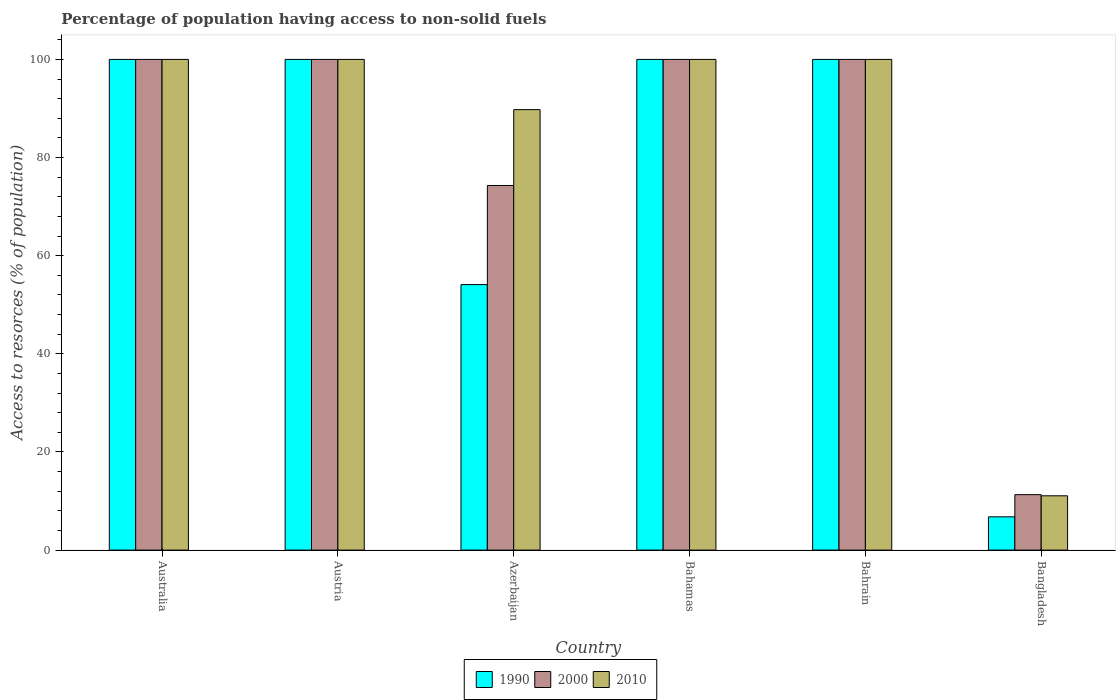Are the number of bars on each tick of the X-axis equal?
Your answer should be compact. Yes. How many bars are there on the 4th tick from the right?
Keep it short and to the point. 3. What is the label of the 1st group of bars from the left?
Offer a very short reply. Australia. Across all countries, what is the minimum percentage of population having access to non-solid fuels in 1990?
Provide a short and direct response. 6.78. In which country was the percentage of population having access to non-solid fuels in 2000 maximum?
Your answer should be very brief. Australia. What is the total percentage of population having access to non-solid fuels in 1990 in the graph?
Your answer should be very brief. 460.89. What is the difference between the percentage of population having access to non-solid fuels in 2010 in Bahamas and that in Bangladesh?
Offer a terse response. 88.93. What is the average percentage of population having access to non-solid fuels in 2010 per country?
Provide a succinct answer. 83.47. What is the difference between the percentage of population having access to non-solid fuels of/in 1990 and percentage of population having access to non-solid fuels of/in 2000 in Bahamas?
Offer a very short reply. 0. In how many countries, is the percentage of population having access to non-solid fuels in 2010 greater than 72 %?
Keep it short and to the point. 5. What is the ratio of the percentage of population having access to non-solid fuels in 2000 in Azerbaijan to that in Bangladesh?
Your answer should be compact. 6.57. Is the percentage of population having access to non-solid fuels in 1990 in Australia less than that in Bahamas?
Keep it short and to the point. No. What is the difference between the highest and the lowest percentage of population having access to non-solid fuels in 2000?
Make the answer very short. 88.7. Is the sum of the percentage of population having access to non-solid fuels in 2000 in Australia and Azerbaijan greater than the maximum percentage of population having access to non-solid fuels in 1990 across all countries?
Make the answer very short. Yes. What does the 1st bar from the left in Azerbaijan represents?
Provide a succinct answer. 1990. What does the 3rd bar from the right in Australia represents?
Offer a terse response. 1990. Is it the case that in every country, the sum of the percentage of population having access to non-solid fuels in 1990 and percentage of population having access to non-solid fuels in 2010 is greater than the percentage of population having access to non-solid fuels in 2000?
Ensure brevity in your answer.  Yes. How many bars are there?
Your answer should be very brief. 18. How many countries are there in the graph?
Make the answer very short. 6. Are the values on the major ticks of Y-axis written in scientific E-notation?
Your answer should be very brief. No. Does the graph contain grids?
Your response must be concise. No. What is the title of the graph?
Your answer should be compact. Percentage of population having access to non-solid fuels. Does "2010" appear as one of the legend labels in the graph?
Offer a very short reply. Yes. What is the label or title of the Y-axis?
Your answer should be very brief. Access to resorces (% of population). What is the Access to resorces (% of population) of 2000 in Australia?
Provide a succinct answer. 100. What is the Access to resorces (% of population) of 2010 in Australia?
Your response must be concise. 100. What is the Access to resorces (% of population) in 1990 in Austria?
Your answer should be very brief. 100. What is the Access to resorces (% of population) in 1990 in Azerbaijan?
Provide a short and direct response. 54.11. What is the Access to resorces (% of population) of 2000 in Azerbaijan?
Keep it short and to the point. 74.31. What is the Access to resorces (% of population) in 2010 in Azerbaijan?
Your answer should be compact. 89.76. What is the Access to resorces (% of population) in 2000 in Bahamas?
Ensure brevity in your answer.  100. What is the Access to resorces (% of population) of 1990 in Bahrain?
Keep it short and to the point. 100. What is the Access to resorces (% of population) of 2000 in Bahrain?
Your answer should be compact. 100. What is the Access to resorces (% of population) in 2010 in Bahrain?
Provide a succinct answer. 100. What is the Access to resorces (% of population) of 1990 in Bangladesh?
Provide a short and direct response. 6.78. What is the Access to resorces (% of population) in 2000 in Bangladesh?
Provide a short and direct response. 11.3. What is the Access to resorces (% of population) of 2010 in Bangladesh?
Offer a terse response. 11.07. Across all countries, what is the maximum Access to resorces (% of population) of 2000?
Give a very brief answer. 100. Across all countries, what is the maximum Access to resorces (% of population) in 2010?
Your answer should be very brief. 100. Across all countries, what is the minimum Access to resorces (% of population) in 1990?
Ensure brevity in your answer.  6.78. Across all countries, what is the minimum Access to resorces (% of population) in 2000?
Give a very brief answer. 11.3. Across all countries, what is the minimum Access to resorces (% of population) in 2010?
Provide a succinct answer. 11.07. What is the total Access to resorces (% of population) in 1990 in the graph?
Keep it short and to the point. 460.89. What is the total Access to resorces (% of population) in 2000 in the graph?
Provide a succinct answer. 485.61. What is the total Access to resorces (% of population) in 2010 in the graph?
Provide a short and direct response. 500.83. What is the difference between the Access to resorces (% of population) in 2000 in Australia and that in Austria?
Make the answer very short. 0. What is the difference between the Access to resorces (% of population) in 1990 in Australia and that in Azerbaijan?
Provide a succinct answer. 45.89. What is the difference between the Access to resorces (% of population) in 2000 in Australia and that in Azerbaijan?
Provide a short and direct response. 25.69. What is the difference between the Access to resorces (% of population) of 2010 in Australia and that in Azerbaijan?
Provide a short and direct response. 10.24. What is the difference between the Access to resorces (% of population) in 1990 in Australia and that in Bahamas?
Offer a terse response. 0. What is the difference between the Access to resorces (% of population) in 2000 in Australia and that in Bahamas?
Provide a short and direct response. 0. What is the difference between the Access to resorces (% of population) in 2000 in Australia and that in Bahrain?
Keep it short and to the point. 0. What is the difference between the Access to resorces (% of population) of 1990 in Australia and that in Bangladesh?
Give a very brief answer. 93.22. What is the difference between the Access to resorces (% of population) in 2000 in Australia and that in Bangladesh?
Your response must be concise. 88.7. What is the difference between the Access to resorces (% of population) of 2010 in Australia and that in Bangladesh?
Your answer should be very brief. 88.93. What is the difference between the Access to resorces (% of population) in 1990 in Austria and that in Azerbaijan?
Make the answer very short. 45.89. What is the difference between the Access to resorces (% of population) in 2000 in Austria and that in Azerbaijan?
Offer a very short reply. 25.69. What is the difference between the Access to resorces (% of population) of 2010 in Austria and that in Azerbaijan?
Provide a short and direct response. 10.24. What is the difference between the Access to resorces (% of population) in 2000 in Austria and that in Bahamas?
Your answer should be compact. 0. What is the difference between the Access to resorces (% of population) of 2010 in Austria and that in Bahrain?
Ensure brevity in your answer.  0. What is the difference between the Access to resorces (% of population) of 1990 in Austria and that in Bangladesh?
Provide a short and direct response. 93.22. What is the difference between the Access to resorces (% of population) of 2000 in Austria and that in Bangladesh?
Your answer should be very brief. 88.7. What is the difference between the Access to resorces (% of population) of 2010 in Austria and that in Bangladesh?
Offer a terse response. 88.93. What is the difference between the Access to resorces (% of population) of 1990 in Azerbaijan and that in Bahamas?
Provide a succinct answer. -45.89. What is the difference between the Access to resorces (% of population) in 2000 in Azerbaijan and that in Bahamas?
Your response must be concise. -25.69. What is the difference between the Access to resorces (% of population) of 2010 in Azerbaijan and that in Bahamas?
Your answer should be compact. -10.24. What is the difference between the Access to resorces (% of population) of 1990 in Azerbaijan and that in Bahrain?
Your answer should be very brief. -45.89. What is the difference between the Access to resorces (% of population) in 2000 in Azerbaijan and that in Bahrain?
Offer a very short reply. -25.69. What is the difference between the Access to resorces (% of population) in 2010 in Azerbaijan and that in Bahrain?
Your response must be concise. -10.24. What is the difference between the Access to resorces (% of population) in 1990 in Azerbaijan and that in Bangladesh?
Your answer should be very brief. 47.32. What is the difference between the Access to resorces (% of population) in 2000 in Azerbaijan and that in Bangladesh?
Your answer should be very brief. 63.01. What is the difference between the Access to resorces (% of population) of 2010 in Azerbaijan and that in Bangladesh?
Your answer should be compact. 78.7. What is the difference between the Access to resorces (% of population) in 2000 in Bahamas and that in Bahrain?
Your answer should be very brief. 0. What is the difference between the Access to resorces (% of population) of 1990 in Bahamas and that in Bangladesh?
Keep it short and to the point. 93.22. What is the difference between the Access to resorces (% of population) in 2000 in Bahamas and that in Bangladesh?
Offer a terse response. 88.7. What is the difference between the Access to resorces (% of population) of 2010 in Bahamas and that in Bangladesh?
Your response must be concise. 88.93. What is the difference between the Access to resorces (% of population) of 1990 in Bahrain and that in Bangladesh?
Your response must be concise. 93.22. What is the difference between the Access to resorces (% of population) in 2000 in Bahrain and that in Bangladesh?
Offer a terse response. 88.7. What is the difference between the Access to resorces (% of population) of 2010 in Bahrain and that in Bangladesh?
Provide a short and direct response. 88.93. What is the difference between the Access to resorces (% of population) of 1990 in Australia and the Access to resorces (% of population) of 2000 in Austria?
Provide a short and direct response. 0. What is the difference between the Access to resorces (% of population) of 1990 in Australia and the Access to resorces (% of population) of 2010 in Austria?
Your answer should be very brief. 0. What is the difference between the Access to resorces (% of population) of 2000 in Australia and the Access to resorces (% of population) of 2010 in Austria?
Offer a very short reply. 0. What is the difference between the Access to resorces (% of population) in 1990 in Australia and the Access to resorces (% of population) in 2000 in Azerbaijan?
Provide a short and direct response. 25.69. What is the difference between the Access to resorces (% of population) of 1990 in Australia and the Access to resorces (% of population) of 2010 in Azerbaijan?
Ensure brevity in your answer.  10.24. What is the difference between the Access to resorces (% of population) in 2000 in Australia and the Access to resorces (% of population) in 2010 in Azerbaijan?
Give a very brief answer. 10.24. What is the difference between the Access to resorces (% of population) in 2000 in Australia and the Access to resorces (% of population) in 2010 in Bahamas?
Offer a very short reply. 0. What is the difference between the Access to resorces (% of population) in 1990 in Australia and the Access to resorces (% of population) in 2010 in Bahrain?
Your answer should be compact. 0. What is the difference between the Access to resorces (% of population) in 1990 in Australia and the Access to resorces (% of population) in 2000 in Bangladesh?
Your answer should be very brief. 88.7. What is the difference between the Access to resorces (% of population) in 1990 in Australia and the Access to resorces (% of population) in 2010 in Bangladesh?
Provide a short and direct response. 88.93. What is the difference between the Access to resorces (% of population) in 2000 in Australia and the Access to resorces (% of population) in 2010 in Bangladesh?
Your response must be concise. 88.93. What is the difference between the Access to resorces (% of population) in 1990 in Austria and the Access to resorces (% of population) in 2000 in Azerbaijan?
Give a very brief answer. 25.69. What is the difference between the Access to resorces (% of population) in 1990 in Austria and the Access to resorces (% of population) in 2010 in Azerbaijan?
Provide a succinct answer. 10.24. What is the difference between the Access to resorces (% of population) of 2000 in Austria and the Access to resorces (% of population) of 2010 in Azerbaijan?
Ensure brevity in your answer.  10.24. What is the difference between the Access to resorces (% of population) of 1990 in Austria and the Access to resorces (% of population) of 2010 in Bahamas?
Keep it short and to the point. 0. What is the difference between the Access to resorces (% of population) of 1990 in Austria and the Access to resorces (% of population) of 2000 in Bahrain?
Your response must be concise. 0. What is the difference between the Access to resorces (% of population) in 2000 in Austria and the Access to resorces (% of population) in 2010 in Bahrain?
Make the answer very short. 0. What is the difference between the Access to resorces (% of population) in 1990 in Austria and the Access to resorces (% of population) in 2000 in Bangladesh?
Offer a terse response. 88.7. What is the difference between the Access to resorces (% of population) in 1990 in Austria and the Access to resorces (% of population) in 2010 in Bangladesh?
Offer a terse response. 88.93. What is the difference between the Access to resorces (% of population) of 2000 in Austria and the Access to resorces (% of population) of 2010 in Bangladesh?
Provide a succinct answer. 88.93. What is the difference between the Access to resorces (% of population) in 1990 in Azerbaijan and the Access to resorces (% of population) in 2000 in Bahamas?
Provide a succinct answer. -45.89. What is the difference between the Access to resorces (% of population) of 1990 in Azerbaijan and the Access to resorces (% of population) of 2010 in Bahamas?
Your answer should be compact. -45.89. What is the difference between the Access to resorces (% of population) in 2000 in Azerbaijan and the Access to resorces (% of population) in 2010 in Bahamas?
Your answer should be compact. -25.69. What is the difference between the Access to resorces (% of population) of 1990 in Azerbaijan and the Access to resorces (% of population) of 2000 in Bahrain?
Offer a very short reply. -45.89. What is the difference between the Access to resorces (% of population) in 1990 in Azerbaijan and the Access to resorces (% of population) in 2010 in Bahrain?
Offer a very short reply. -45.89. What is the difference between the Access to resorces (% of population) in 2000 in Azerbaijan and the Access to resorces (% of population) in 2010 in Bahrain?
Your answer should be compact. -25.69. What is the difference between the Access to resorces (% of population) of 1990 in Azerbaijan and the Access to resorces (% of population) of 2000 in Bangladesh?
Offer a very short reply. 42.8. What is the difference between the Access to resorces (% of population) in 1990 in Azerbaijan and the Access to resorces (% of population) in 2010 in Bangladesh?
Your answer should be compact. 43.04. What is the difference between the Access to resorces (% of population) in 2000 in Azerbaijan and the Access to resorces (% of population) in 2010 in Bangladesh?
Your response must be concise. 63.24. What is the difference between the Access to resorces (% of population) of 1990 in Bahamas and the Access to resorces (% of population) of 2010 in Bahrain?
Give a very brief answer. 0. What is the difference between the Access to resorces (% of population) of 2000 in Bahamas and the Access to resorces (% of population) of 2010 in Bahrain?
Keep it short and to the point. 0. What is the difference between the Access to resorces (% of population) of 1990 in Bahamas and the Access to resorces (% of population) of 2000 in Bangladesh?
Keep it short and to the point. 88.7. What is the difference between the Access to resorces (% of population) of 1990 in Bahamas and the Access to resorces (% of population) of 2010 in Bangladesh?
Give a very brief answer. 88.93. What is the difference between the Access to resorces (% of population) of 2000 in Bahamas and the Access to resorces (% of population) of 2010 in Bangladesh?
Provide a succinct answer. 88.93. What is the difference between the Access to resorces (% of population) in 1990 in Bahrain and the Access to resorces (% of population) in 2000 in Bangladesh?
Your answer should be very brief. 88.7. What is the difference between the Access to resorces (% of population) in 1990 in Bahrain and the Access to resorces (% of population) in 2010 in Bangladesh?
Your response must be concise. 88.93. What is the difference between the Access to resorces (% of population) of 2000 in Bahrain and the Access to resorces (% of population) of 2010 in Bangladesh?
Your response must be concise. 88.93. What is the average Access to resorces (% of population) of 1990 per country?
Provide a succinct answer. 76.81. What is the average Access to resorces (% of population) in 2000 per country?
Provide a succinct answer. 80.93. What is the average Access to resorces (% of population) of 2010 per country?
Your answer should be very brief. 83.47. What is the difference between the Access to resorces (% of population) of 1990 and Access to resorces (% of population) of 2000 in Australia?
Your response must be concise. 0. What is the difference between the Access to resorces (% of population) in 2000 and Access to resorces (% of population) in 2010 in Australia?
Ensure brevity in your answer.  0. What is the difference between the Access to resorces (% of population) of 1990 and Access to resorces (% of population) of 2010 in Austria?
Offer a very short reply. 0. What is the difference between the Access to resorces (% of population) of 2000 and Access to resorces (% of population) of 2010 in Austria?
Make the answer very short. 0. What is the difference between the Access to resorces (% of population) in 1990 and Access to resorces (% of population) in 2000 in Azerbaijan?
Your answer should be compact. -20.2. What is the difference between the Access to resorces (% of population) in 1990 and Access to resorces (% of population) in 2010 in Azerbaijan?
Provide a succinct answer. -35.66. What is the difference between the Access to resorces (% of population) of 2000 and Access to resorces (% of population) of 2010 in Azerbaijan?
Offer a terse response. -15.46. What is the difference between the Access to resorces (% of population) in 1990 and Access to resorces (% of population) in 2000 in Bahamas?
Your answer should be compact. 0. What is the difference between the Access to resorces (% of population) in 1990 and Access to resorces (% of population) in 2010 in Bahamas?
Your response must be concise. 0. What is the difference between the Access to resorces (% of population) of 2000 and Access to resorces (% of population) of 2010 in Bahamas?
Your answer should be very brief. 0. What is the difference between the Access to resorces (% of population) in 1990 and Access to resorces (% of population) in 2000 in Bahrain?
Provide a short and direct response. 0. What is the difference between the Access to resorces (% of population) of 1990 and Access to resorces (% of population) of 2000 in Bangladesh?
Your answer should be compact. -4.52. What is the difference between the Access to resorces (% of population) in 1990 and Access to resorces (% of population) in 2010 in Bangladesh?
Give a very brief answer. -4.28. What is the difference between the Access to resorces (% of population) in 2000 and Access to resorces (% of population) in 2010 in Bangladesh?
Provide a succinct answer. 0.24. What is the ratio of the Access to resorces (% of population) of 1990 in Australia to that in Austria?
Give a very brief answer. 1. What is the ratio of the Access to resorces (% of population) of 2000 in Australia to that in Austria?
Ensure brevity in your answer.  1. What is the ratio of the Access to resorces (% of population) of 2010 in Australia to that in Austria?
Provide a succinct answer. 1. What is the ratio of the Access to resorces (% of population) of 1990 in Australia to that in Azerbaijan?
Provide a succinct answer. 1.85. What is the ratio of the Access to resorces (% of population) in 2000 in Australia to that in Azerbaijan?
Your response must be concise. 1.35. What is the ratio of the Access to resorces (% of population) in 2010 in Australia to that in Azerbaijan?
Give a very brief answer. 1.11. What is the ratio of the Access to resorces (% of population) in 1990 in Australia to that in Bahamas?
Your answer should be very brief. 1. What is the ratio of the Access to resorces (% of population) of 2000 in Australia to that in Bahamas?
Give a very brief answer. 1. What is the ratio of the Access to resorces (% of population) of 2010 in Australia to that in Bahamas?
Provide a short and direct response. 1. What is the ratio of the Access to resorces (% of population) of 1990 in Australia to that in Bahrain?
Your response must be concise. 1. What is the ratio of the Access to resorces (% of population) in 1990 in Australia to that in Bangladesh?
Provide a short and direct response. 14.74. What is the ratio of the Access to resorces (% of population) in 2000 in Australia to that in Bangladesh?
Your answer should be compact. 8.85. What is the ratio of the Access to resorces (% of population) of 2010 in Australia to that in Bangladesh?
Your response must be concise. 9.04. What is the ratio of the Access to resorces (% of population) in 1990 in Austria to that in Azerbaijan?
Your answer should be compact. 1.85. What is the ratio of the Access to resorces (% of population) of 2000 in Austria to that in Azerbaijan?
Offer a terse response. 1.35. What is the ratio of the Access to resorces (% of population) of 2010 in Austria to that in Azerbaijan?
Your response must be concise. 1.11. What is the ratio of the Access to resorces (% of population) in 1990 in Austria to that in Bahamas?
Your answer should be very brief. 1. What is the ratio of the Access to resorces (% of population) in 2000 in Austria to that in Bahamas?
Ensure brevity in your answer.  1. What is the ratio of the Access to resorces (% of population) of 2010 in Austria to that in Bahamas?
Provide a succinct answer. 1. What is the ratio of the Access to resorces (% of population) in 2010 in Austria to that in Bahrain?
Ensure brevity in your answer.  1. What is the ratio of the Access to resorces (% of population) of 1990 in Austria to that in Bangladesh?
Your response must be concise. 14.74. What is the ratio of the Access to resorces (% of population) of 2000 in Austria to that in Bangladesh?
Ensure brevity in your answer.  8.85. What is the ratio of the Access to resorces (% of population) in 2010 in Austria to that in Bangladesh?
Provide a succinct answer. 9.04. What is the ratio of the Access to resorces (% of population) in 1990 in Azerbaijan to that in Bahamas?
Give a very brief answer. 0.54. What is the ratio of the Access to resorces (% of population) of 2000 in Azerbaijan to that in Bahamas?
Offer a very short reply. 0.74. What is the ratio of the Access to resorces (% of population) in 2010 in Azerbaijan to that in Bahamas?
Provide a short and direct response. 0.9. What is the ratio of the Access to resorces (% of population) of 1990 in Azerbaijan to that in Bahrain?
Provide a succinct answer. 0.54. What is the ratio of the Access to resorces (% of population) of 2000 in Azerbaijan to that in Bahrain?
Offer a very short reply. 0.74. What is the ratio of the Access to resorces (% of population) in 2010 in Azerbaijan to that in Bahrain?
Ensure brevity in your answer.  0.9. What is the ratio of the Access to resorces (% of population) in 1990 in Azerbaijan to that in Bangladesh?
Keep it short and to the point. 7.98. What is the ratio of the Access to resorces (% of population) of 2000 in Azerbaijan to that in Bangladesh?
Keep it short and to the point. 6.58. What is the ratio of the Access to resorces (% of population) in 2010 in Azerbaijan to that in Bangladesh?
Keep it short and to the point. 8.11. What is the ratio of the Access to resorces (% of population) of 1990 in Bahamas to that in Bahrain?
Offer a terse response. 1. What is the ratio of the Access to resorces (% of population) of 2000 in Bahamas to that in Bahrain?
Your answer should be very brief. 1. What is the ratio of the Access to resorces (% of population) in 2010 in Bahamas to that in Bahrain?
Offer a terse response. 1. What is the ratio of the Access to resorces (% of population) in 1990 in Bahamas to that in Bangladesh?
Give a very brief answer. 14.74. What is the ratio of the Access to resorces (% of population) of 2000 in Bahamas to that in Bangladesh?
Keep it short and to the point. 8.85. What is the ratio of the Access to resorces (% of population) of 2010 in Bahamas to that in Bangladesh?
Your answer should be very brief. 9.04. What is the ratio of the Access to resorces (% of population) of 1990 in Bahrain to that in Bangladesh?
Keep it short and to the point. 14.74. What is the ratio of the Access to resorces (% of population) in 2000 in Bahrain to that in Bangladesh?
Ensure brevity in your answer.  8.85. What is the ratio of the Access to resorces (% of population) in 2010 in Bahrain to that in Bangladesh?
Ensure brevity in your answer.  9.04. What is the difference between the highest and the second highest Access to resorces (% of population) in 1990?
Provide a short and direct response. 0. What is the difference between the highest and the lowest Access to resorces (% of population) of 1990?
Your answer should be compact. 93.22. What is the difference between the highest and the lowest Access to resorces (% of population) of 2000?
Your answer should be very brief. 88.7. What is the difference between the highest and the lowest Access to resorces (% of population) of 2010?
Your answer should be compact. 88.93. 